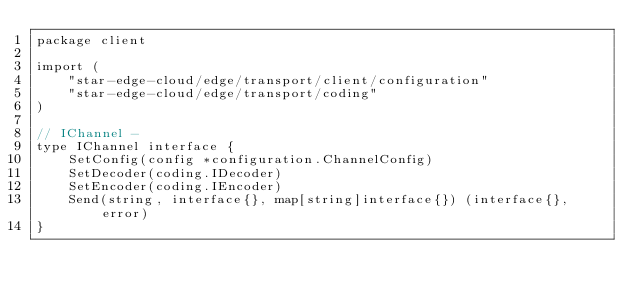Convert code to text. <code><loc_0><loc_0><loc_500><loc_500><_Go_>package client

import (
	"star-edge-cloud/edge/transport/client/configuration"
	"star-edge-cloud/edge/transport/coding"
)

// IChannel -
type IChannel interface {
	SetConfig(config *configuration.ChannelConfig)
	SetDecoder(coding.IDecoder)
	SetEncoder(coding.IEncoder)
	Send(string, interface{}, map[string]interface{}) (interface{}, error)
}
</code> 